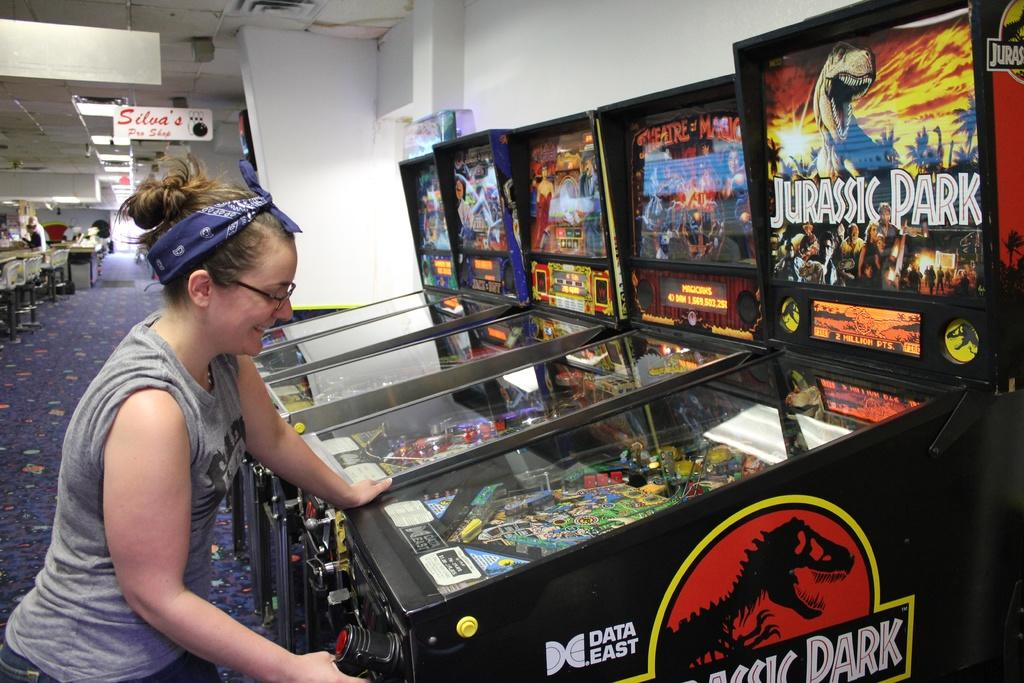Who is present in the image? There is a woman in the image. What is the woman wearing? The woman is wearing spectacles. What expression does the woman have? The woman is smiling. What type of machines can be seen in the image? There are gaming machines in the image. What is the setting of the image? The image shows a floor and a wall in the background. What else can be seen in the background of the image? There is a board and lights in the background of the image. What type of airplane is the woman flying in the image? There is no airplane present in the image; it features a woman with gaming machines in the background. 